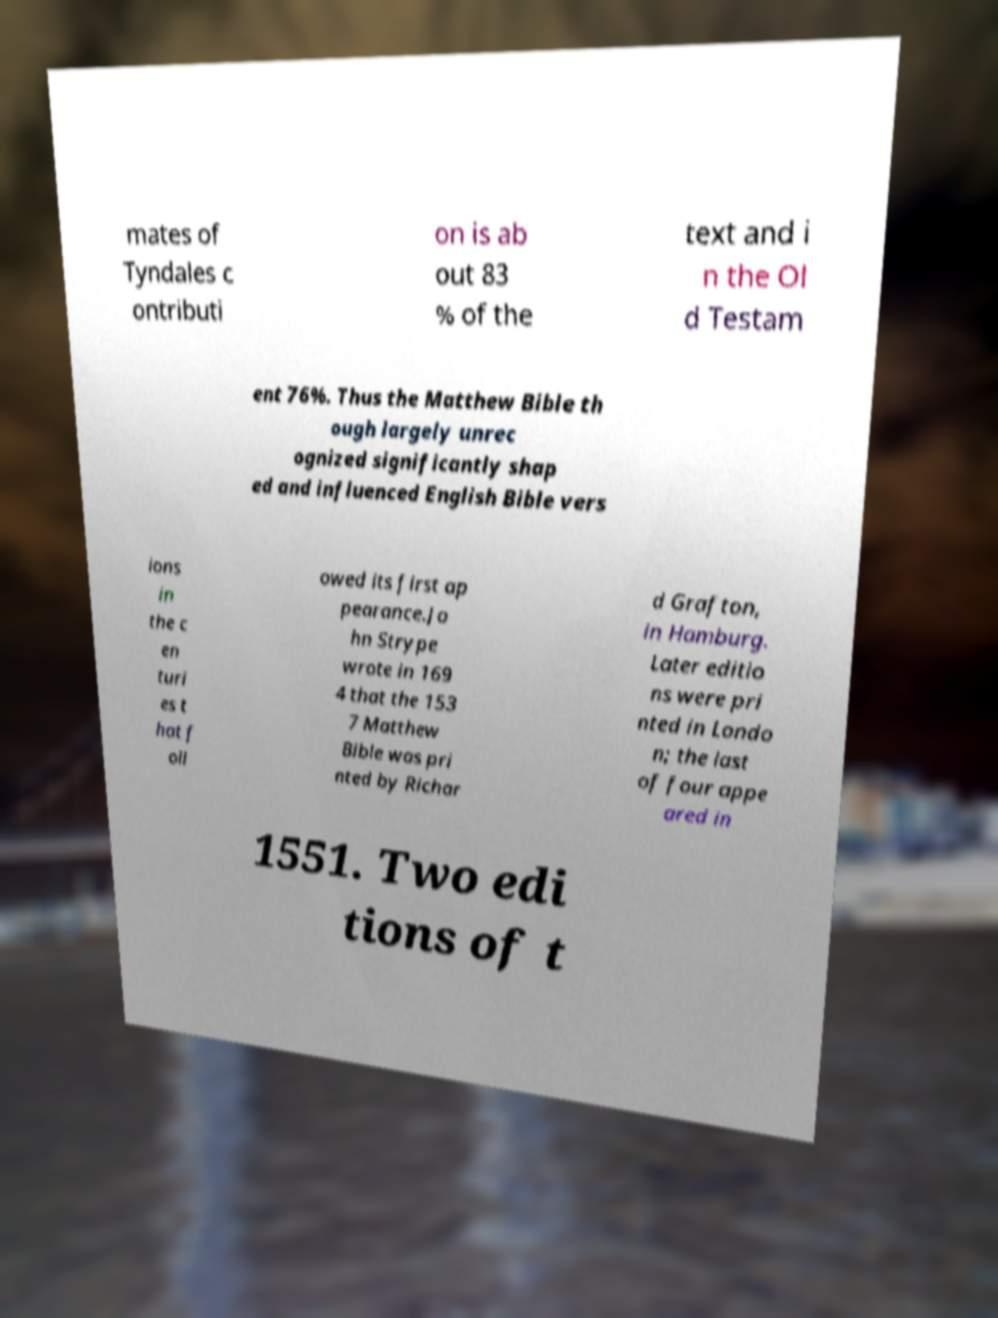For documentation purposes, I need the text within this image transcribed. Could you provide that? mates of Tyndales c ontributi on is ab out 83 % of the text and i n the Ol d Testam ent 76%. Thus the Matthew Bible th ough largely unrec ognized significantly shap ed and influenced English Bible vers ions in the c en turi es t hat f oll owed its first ap pearance.Jo hn Strype wrote in 169 4 that the 153 7 Matthew Bible was pri nted by Richar d Grafton, in Hamburg. Later editio ns were pri nted in Londo n; the last of four appe ared in 1551. Two edi tions of t 